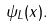Convert formula to latex. <formula><loc_0><loc_0><loc_500><loc_500>\psi _ { L } ( x ) .</formula> 